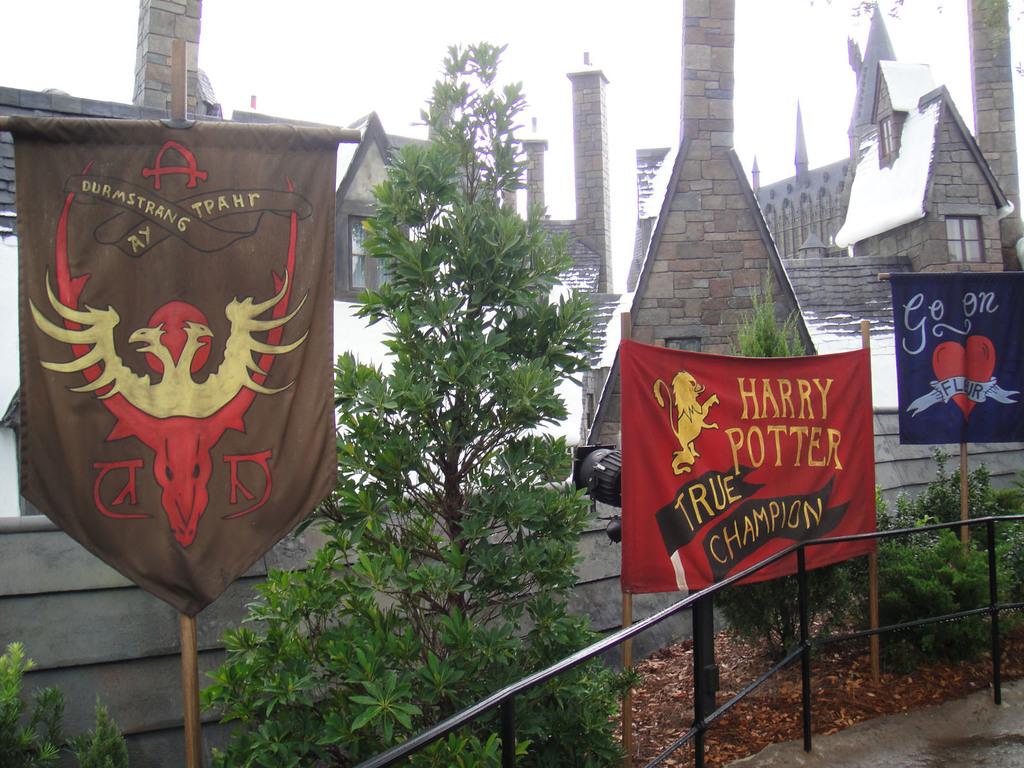Who is a true champion?
Give a very brief answer. Harry potter. What is written on the red flag?
Provide a short and direct response. Harry potter true champion. 